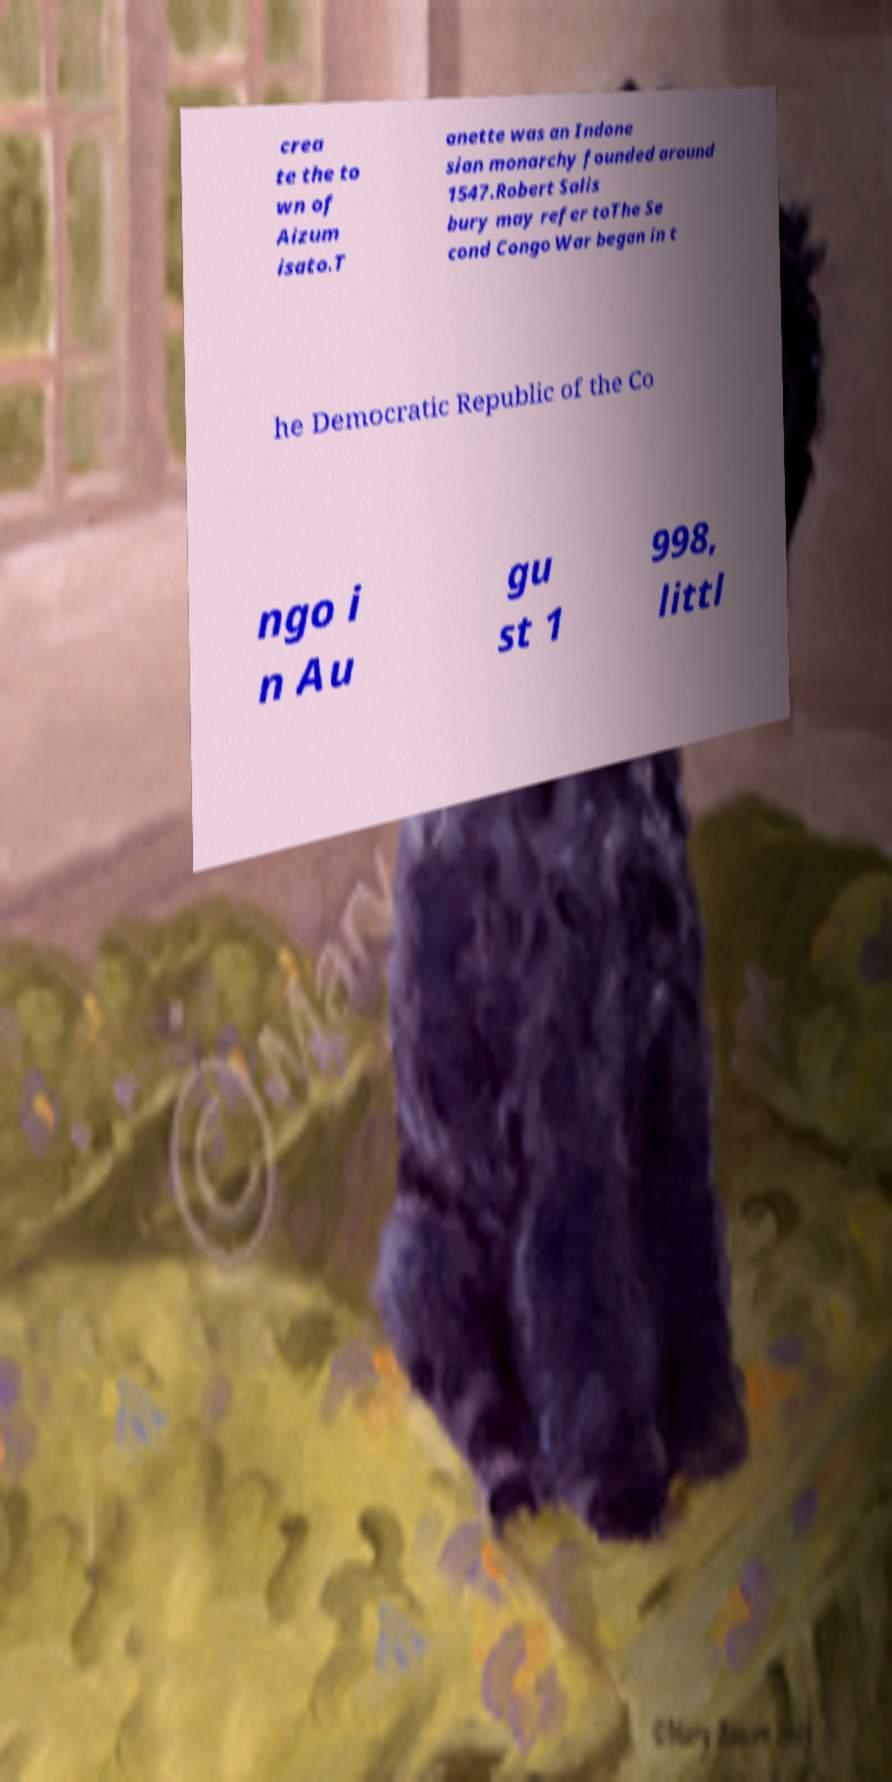Can you accurately transcribe the text from the provided image for me? crea te the to wn of Aizum isato.T anette was an Indone sian monarchy founded around 1547.Robert Salis bury may refer toThe Se cond Congo War began in t he Democratic Republic of the Co ngo i n Au gu st 1 998, littl 